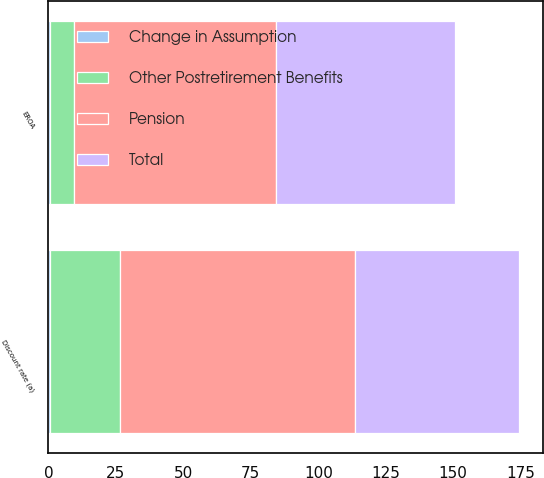Convert chart. <chart><loc_0><loc_0><loc_500><loc_500><stacked_bar_chart><ecel><fcel>Discount rate (a)<fcel>EROA<nl><fcel>Change in Assumption<fcel>0.5<fcel>0.5<nl><fcel>Total<fcel>61<fcel>66<nl><fcel>Other Postretirement Benefits<fcel>26<fcel>9<nl><fcel>Pension<fcel>87<fcel>75<nl></chart> 